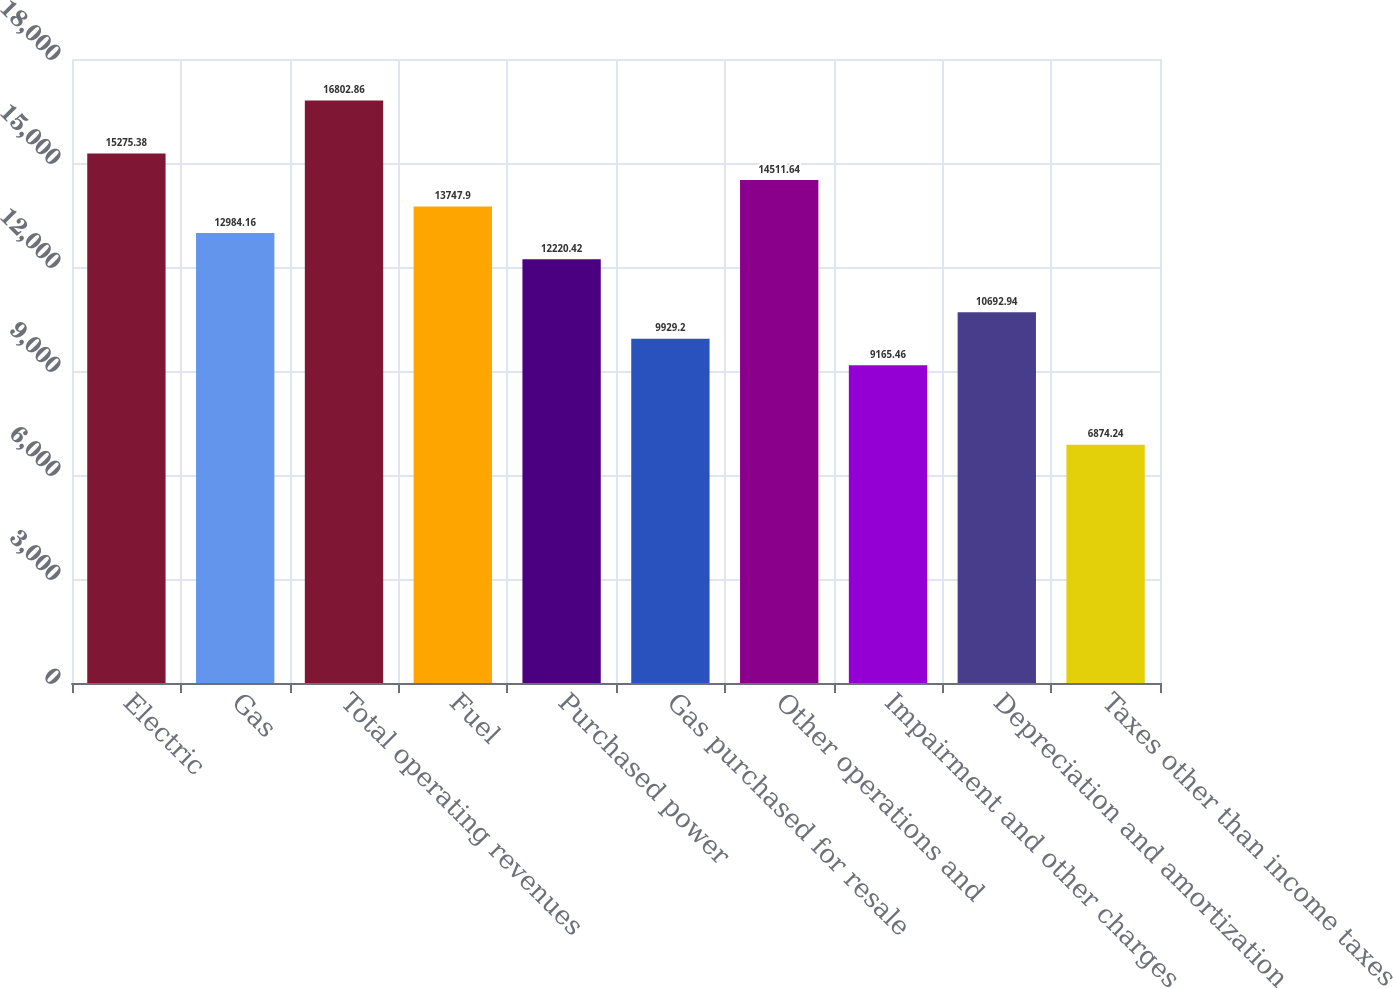Convert chart. <chart><loc_0><loc_0><loc_500><loc_500><bar_chart><fcel>Electric<fcel>Gas<fcel>Total operating revenues<fcel>Fuel<fcel>Purchased power<fcel>Gas purchased for resale<fcel>Other operations and<fcel>Impairment and other charges<fcel>Depreciation and amortization<fcel>Taxes other than income taxes<nl><fcel>15275.4<fcel>12984.2<fcel>16802.9<fcel>13747.9<fcel>12220.4<fcel>9929.2<fcel>14511.6<fcel>9165.46<fcel>10692.9<fcel>6874.24<nl></chart> 